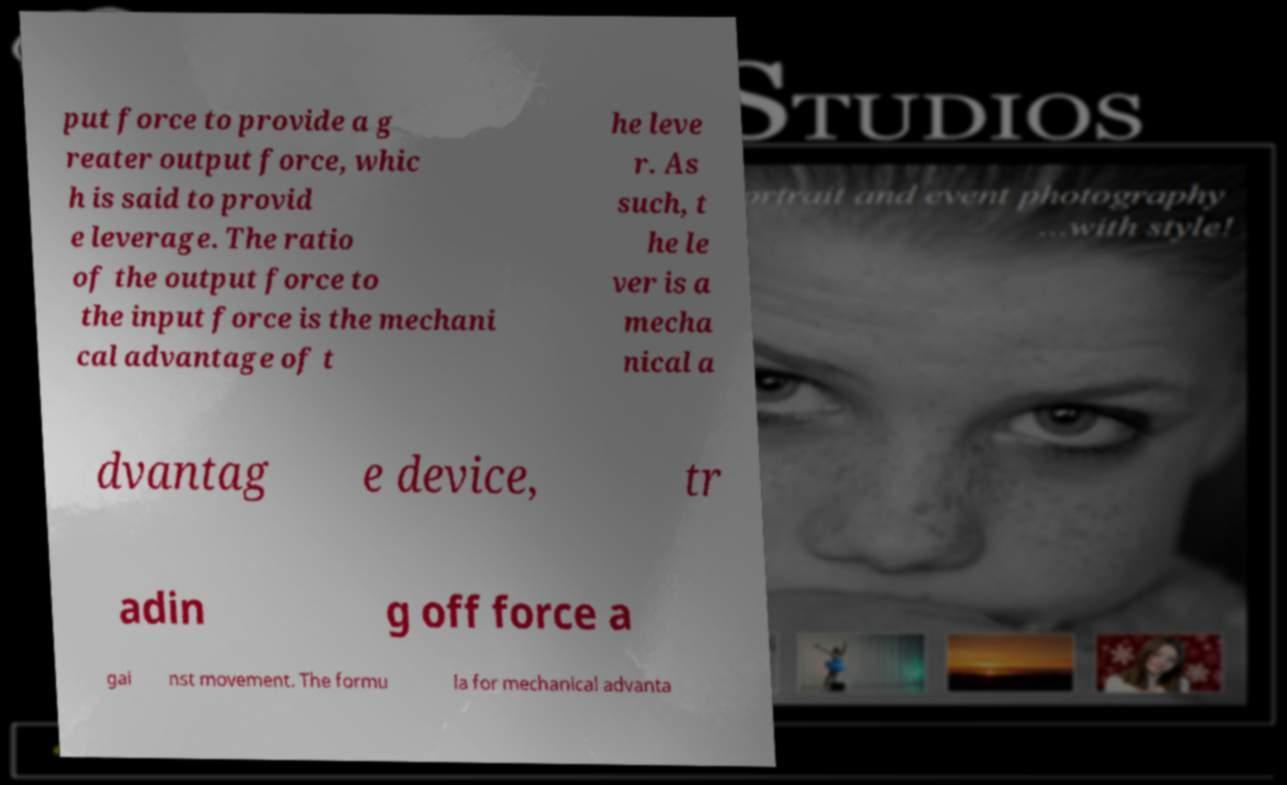Could you assist in decoding the text presented in this image and type it out clearly? put force to provide a g reater output force, whic h is said to provid e leverage. The ratio of the output force to the input force is the mechani cal advantage of t he leve r. As such, t he le ver is a mecha nical a dvantag e device, tr adin g off force a gai nst movement. The formu la for mechanical advanta 